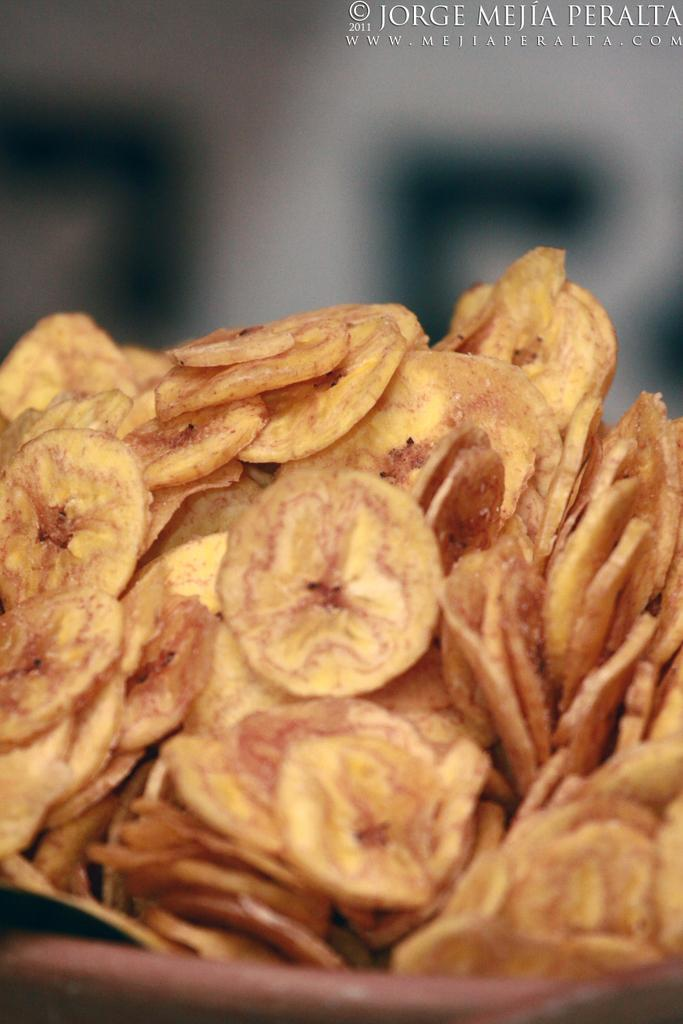What type of food is visible in the image? There are banana chips in the image. Is there a lawyer present in the image to give their approval for the banana chips? There is no lawyer present in the image, nor is there any indication of seeking approval for the banana chips. 